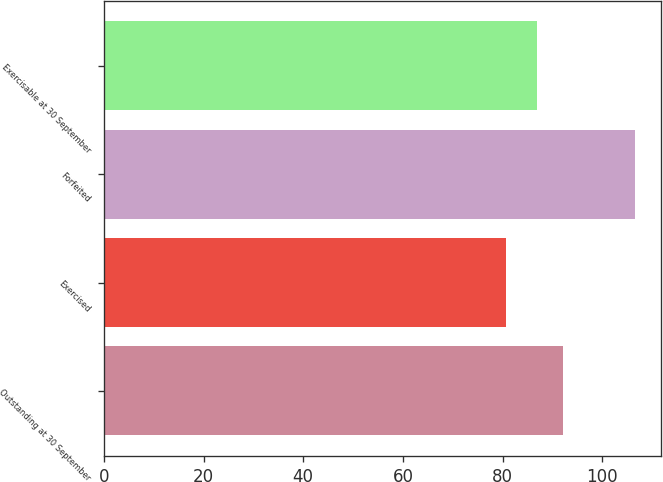Convert chart. <chart><loc_0><loc_0><loc_500><loc_500><bar_chart><fcel>Outstanding at 30 September<fcel>Exercised<fcel>Forfeited<fcel>Exercisable at 30 September<nl><fcel>92.17<fcel>80.66<fcel>106.52<fcel>86.99<nl></chart> 